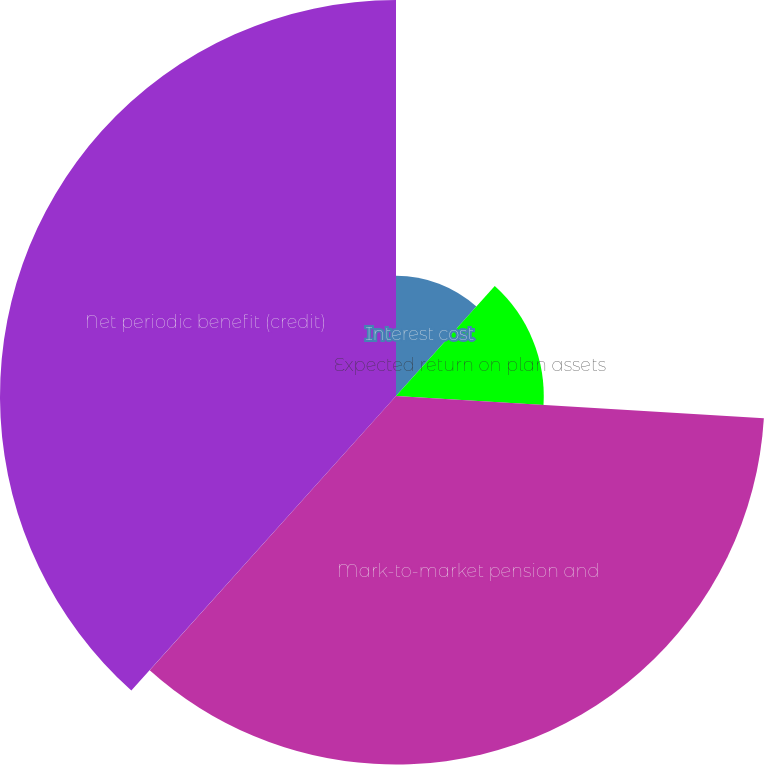Convert chart to OTSL. <chart><loc_0><loc_0><loc_500><loc_500><pie_chart><fcel>Interest cost<fcel>Expected return on plan assets<fcel>Mark-to-market pension and<fcel>Net periodic benefit (credit)<nl><fcel>11.65%<fcel>14.31%<fcel>35.69%<fcel>38.35%<nl></chart> 